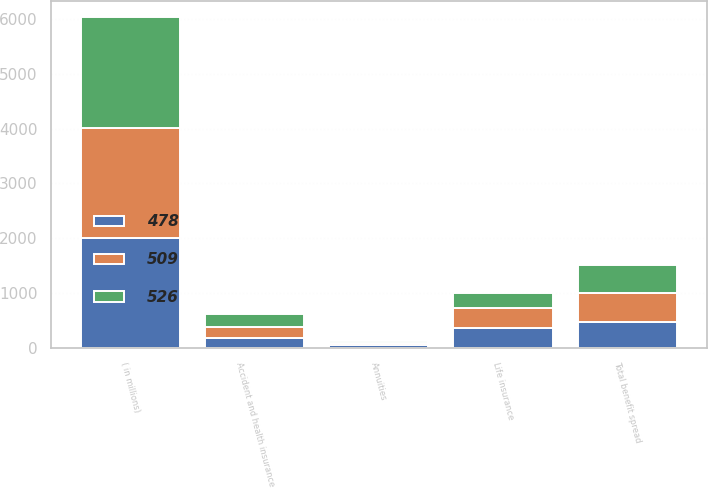<chart> <loc_0><loc_0><loc_500><loc_500><stacked_bar_chart><ecel><fcel>( in millions)<fcel>Life insurance<fcel>Accident and health insurance<fcel>Annuities<fcel>Total benefit spread<nl><fcel>526<fcel>2010<fcel>282<fcel>252<fcel>25<fcel>509<nl><fcel>509<fcel>2009<fcel>363<fcel>196<fcel>33<fcel>526<nl><fcel>478<fcel>2008<fcel>363<fcel>177<fcel>62<fcel>478<nl></chart> 